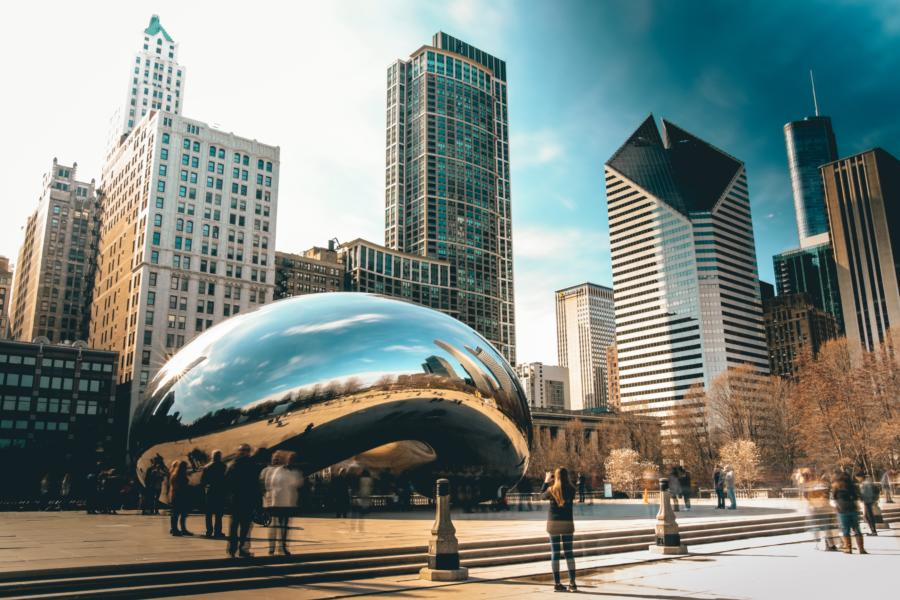What impact does the reflective surface of The Bean have on the viewer's experience? The Bean's reflective surface creates a unique visual experience where the viewer becomes part of the artwork. As the cityscape and the faces of countless visitors merge on its polished, curved surface, it distorts and amplifies images, making each perspective unique. This encourages personal interaction and a playful exploration, making it a popular subject for photography and a striking example of public art influencing personal and collective experience. 